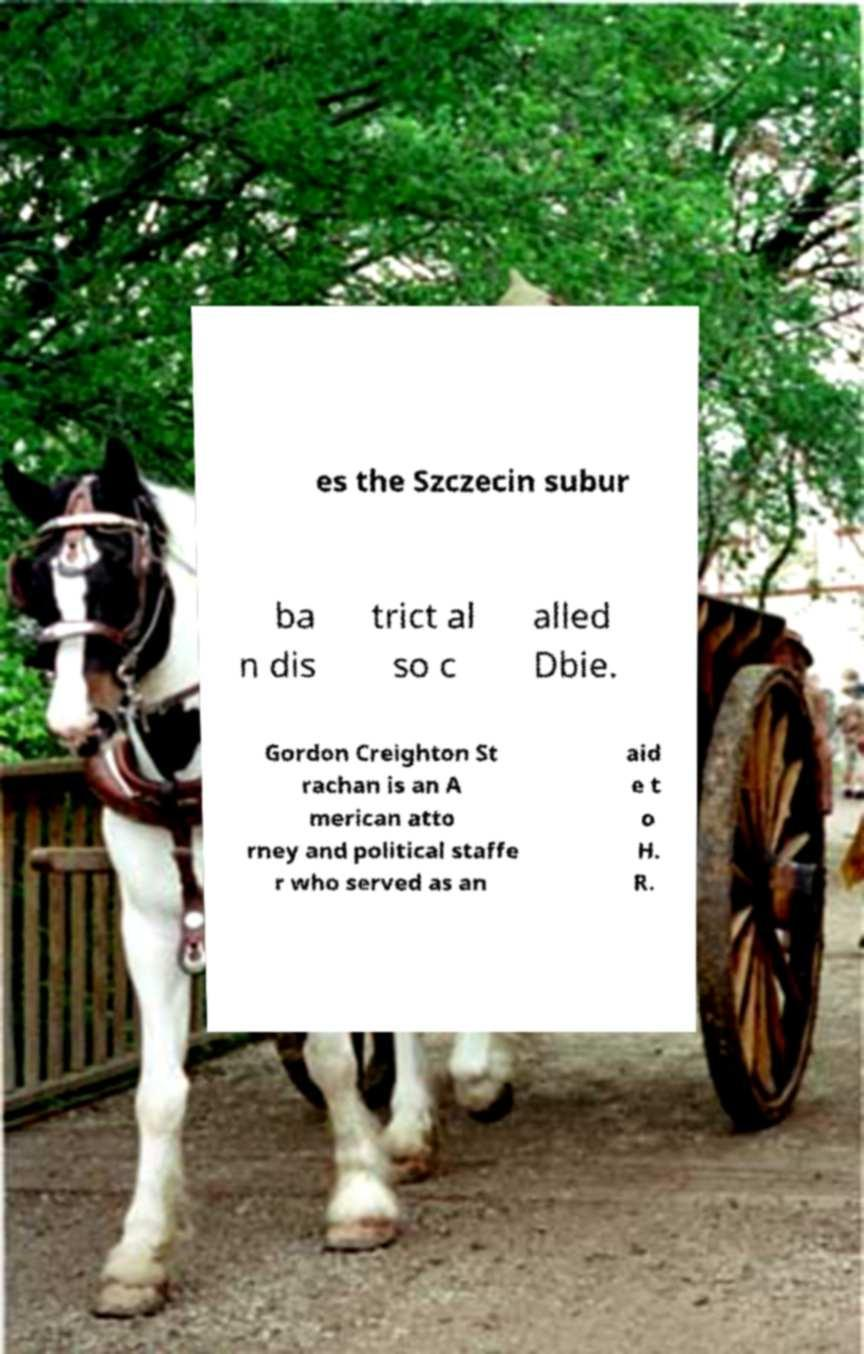Could you assist in decoding the text presented in this image and type it out clearly? es the Szczecin subur ba n dis trict al so c alled Dbie. Gordon Creighton St rachan is an A merican atto rney and political staffe r who served as an aid e t o H. R. 